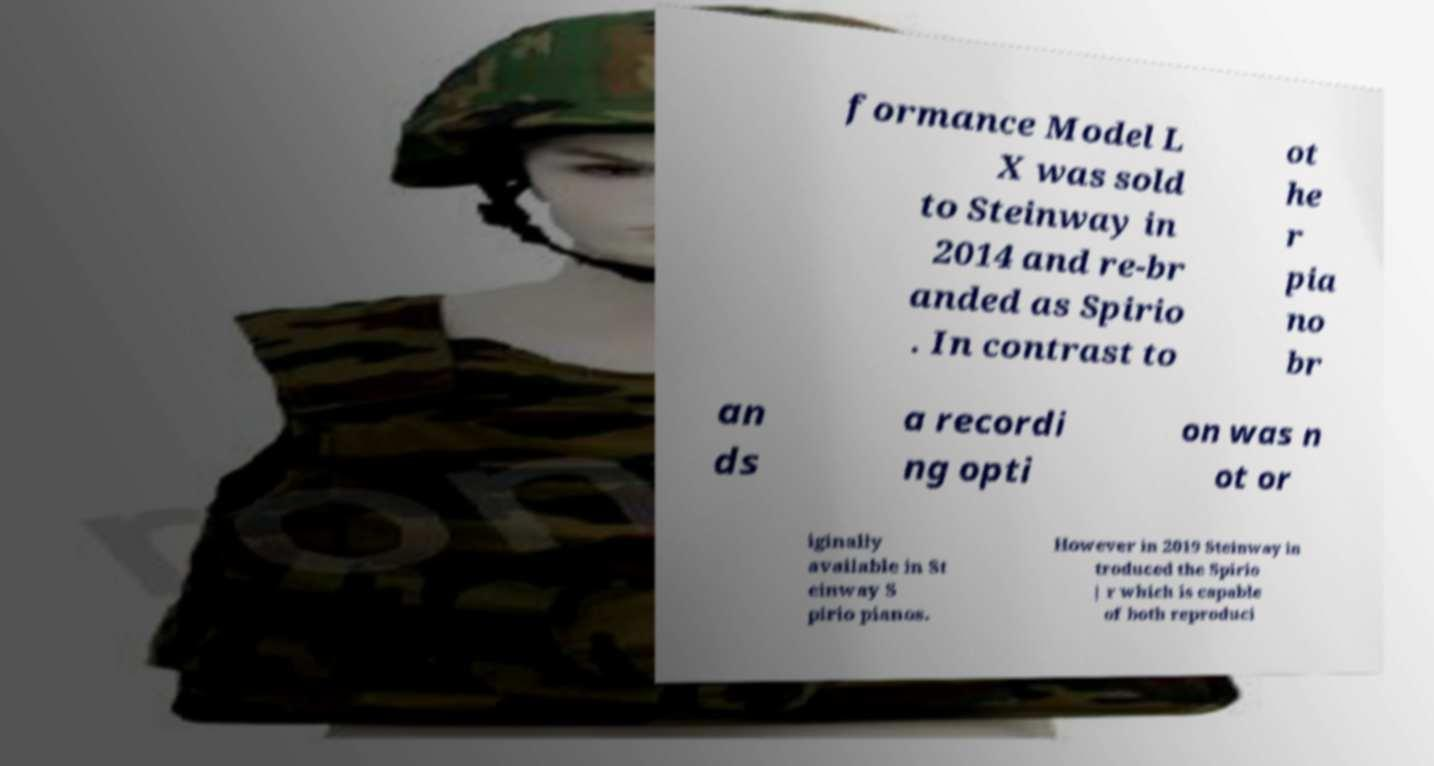There's text embedded in this image that I need extracted. Can you transcribe it verbatim? formance Model L X was sold to Steinway in 2014 and re-br anded as Spirio . In contrast to ot he r pia no br an ds a recordi ng opti on was n ot or iginally available in St einway S pirio pianos. However in 2019 Steinway in troduced the Spirio | r which is capable of both reproduci 